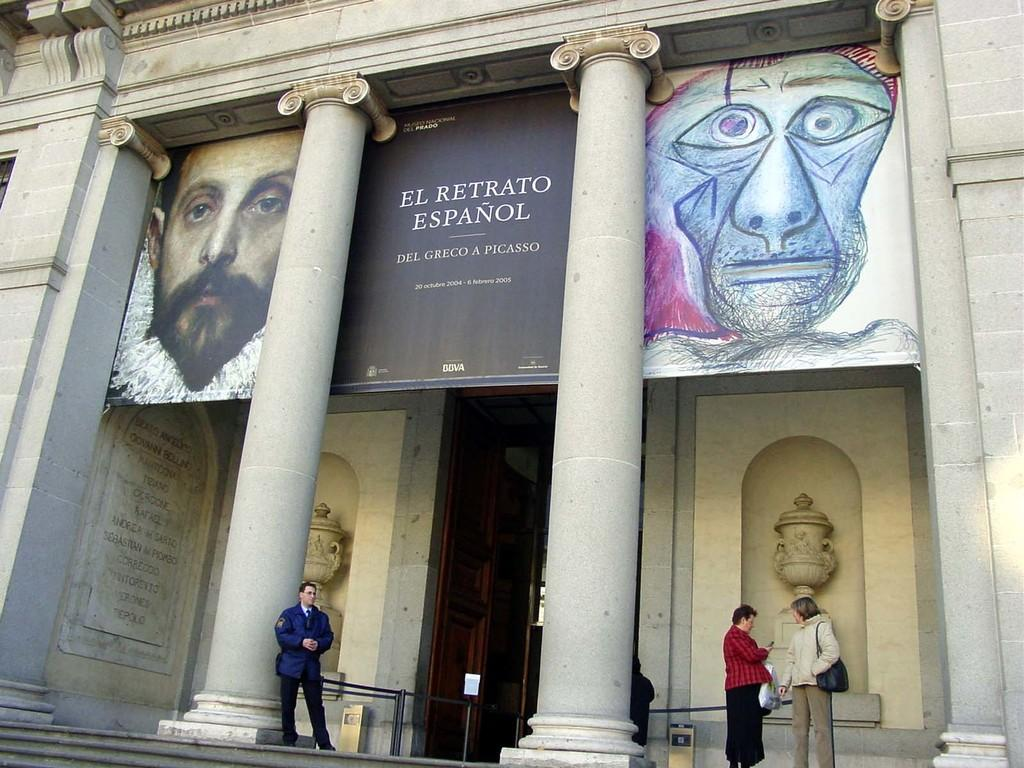How many people are in the image? There are people in the image, but the exact number is not specified. What type of structure is visible in the image? There is a building in the image. Can you describe any architectural features in the image? Yes, there is a pillar, stairs, and a wall with a door in the image. What is written on the wall in the image? There is text on the wall in the image. What is depicted on the poster in the image? There is a poster with images in the image, and there is text on the poster as well. What type of mask is the person wearing in the image? There is no person wearing a mask in the image. How does the horse in the image express anger? There is no horse present in the image, so it cannot express any emotions. 